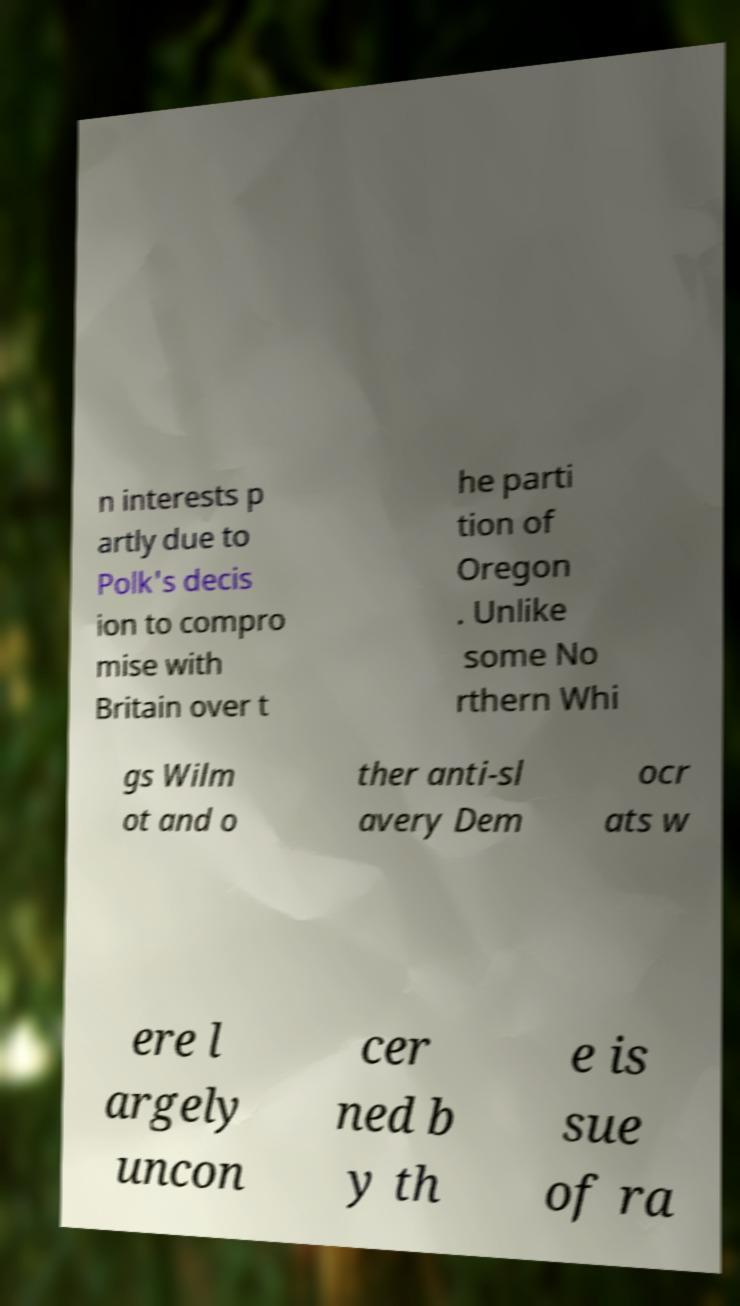I need the written content from this picture converted into text. Can you do that? n interests p artly due to Polk's decis ion to compro mise with Britain over t he parti tion of Oregon . Unlike some No rthern Whi gs Wilm ot and o ther anti-sl avery Dem ocr ats w ere l argely uncon cer ned b y th e is sue of ra 